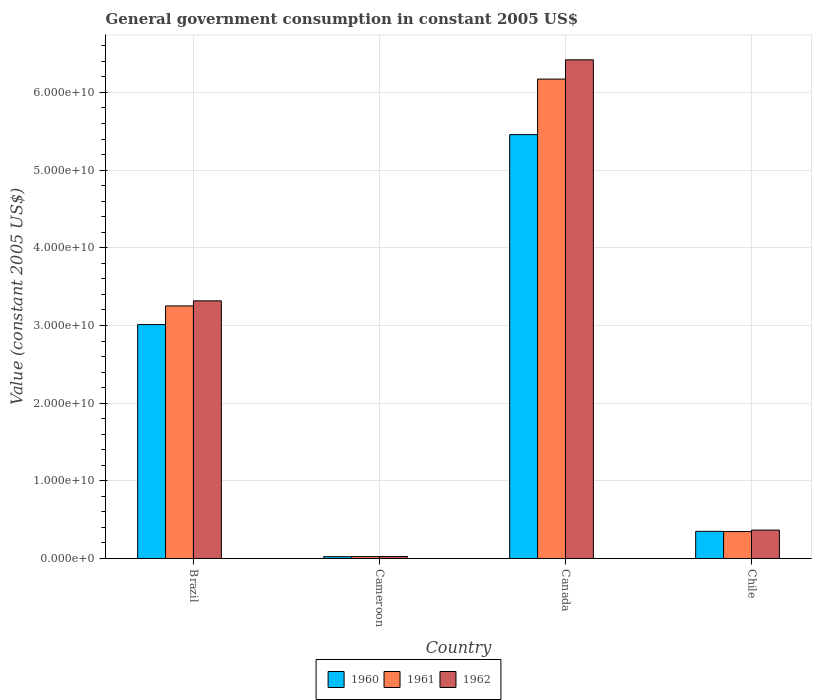How many different coloured bars are there?
Offer a very short reply. 3. How many groups of bars are there?
Provide a succinct answer. 4. Are the number of bars on each tick of the X-axis equal?
Provide a succinct answer. Yes. How many bars are there on the 4th tick from the left?
Offer a terse response. 3. What is the label of the 4th group of bars from the left?
Keep it short and to the point. Chile. What is the government conusmption in 1960 in Cameroon?
Provide a short and direct response. 2.33e+08. Across all countries, what is the maximum government conusmption in 1960?
Your answer should be very brief. 5.46e+1. Across all countries, what is the minimum government conusmption in 1961?
Ensure brevity in your answer.  2.41e+08. In which country was the government conusmption in 1960 maximum?
Offer a terse response. Canada. In which country was the government conusmption in 1961 minimum?
Ensure brevity in your answer.  Cameroon. What is the total government conusmption in 1962 in the graph?
Make the answer very short. 1.01e+11. What is the difference between the government conusmption in 1961 in Cameroon and that in Chile?
Ensure brevity in your answer.  -3.23e+09. What is the difference between the government conusmption in 1961 in Brazil and the government conusmption in 1960 in Canada?
Keep it short and to the point. -2.21e+1. What is the average government conusmption in 1962 per country?
Offer a terse response. 2.53e+1. What is the difference between the government conusmption of/in 1961 and government conusmption of/in 1960 in Brazil?
Your answer should be very brief. 2.40e+09. What is the ratio of the government conusmption in 1960 in Brazil to that in Canada?
Provide a succinct answer. 0.55. Is the government conusmption in 1962 in Cameroon less than that in Chile?
Your answer should be very brief. Yes. What is the difference between the highest and the second highest government conusmption in 1960?
Your answer should be very brief. 2.45e+1. What is the difference between the highest and the lowest government conusmption in 1962?
Keep it short and to the point. 6.40e+1. In how many countries, is the government conusmption in 1960 greater than the average government conusmption in 1960 taken over all countries?
Give a very brief answer. 2. Is the sum of the government conusmption in 1962 in Canada and Chile greater than the maximum government conusmption in 1961 across all countries?
Keep it short and to the point. Yes. What does the 3rd bar from the left in Chile represents?
Give a very brief answer. 1962. Is it the case that in every country, the sum of the government conusmption in 1961 and government conusmption in 1960 is greater than the government conusmption in 1962?
Keep it short and to the point. Yes. Does the graph contain any zero values?
Provide a succinct answer. No. Where does the legend appear in the graph?
Ensure brevity in your answer.  Bottom center. What is the title of the graph?
Provide a succinct answer. General government consumption in constant 2005 US$. What is the label or title of the Y-axis?
Your answer should be very brief. Value (constant 2005 US$). What is the Value (constant 2005 US$) in 1960 in Brazil?
Offer a terse response. 3.01e+1. What is the Value (constant 2005 US$) in 1961 in Brazil?
Your response must be concise. 3.25e+1. What is the Value (constant 2005 US$) in 1962 in Brazil?
Provide a short and direct response. 3.32e+1. What is the Value (constant 2005 US$) of 1960 in Cameroon?
Ensure brevity in your answer.  2.33e+08. What is the Value (constant 2005 US$) in 1961 in Cameroon?
Offer a terse response. 2.41e+08. What is the Value (constant 2005 US$) in 1962 in Cameroon?
Make the answer very short. 2.54e+08. What is the Value (constant 2005 US$) in 1960 in Canada?
Offer a terse response. 5.46e+1. What is the Value (constant 2005 US$) of 1961 in Canada?
Give a very brief answer. 6.17e+1. What is the Value (constant 2005 US$) in 1962 in Canada?
Give a very brief answer. 6.42e+1. What is the Value (constant 2005 US$) in 1960 in Chile?
Your response must be concise. 3.49e+09. What is the Value (constant 2005 US$) in 1961 in Chile?
Your answer should be very brief. 3.47e+09. What is the Value (constant 2005 US$) of 1962 in Chile?
Your response must be concise. 3.66e+09. Across all countries, what is the maximum Value (constant 2005 US$) of 1960?
Keep it short and to the point. 5.46e+1. Across all countries, what is the maximum Value (constant 2005 US$) in 1961?
Your answer should be very brief. 6.17e+1. Across all countries, what is the maximum Value (constant 2005 US$) of 1962?
Provide a succinct answer. 6.42e+1. Across all countries, what is the minimum Value (constant 2005 US$) in 1960?
Keep it short and to the point. 2.33e+08. Across all countries, what is the minimum Value (constant 2005 US$) of 1961?
Offer a terse response. 2.41e+08. Across all countries, what is the minimum Value (constant 2005 US$) of 1962?
Give a very brief answer. 2.54e+08. What is the total Value (constant 2005 US$) of 1960 in the graph?
Keep it short and to the point. 8.84e+1. What is the total Value (constant 2005 US$) of 1961 in the graph?
Make the answer very short. 9.80e+1. What is the total Value (constant 2005 US$) in 1962 in the graph?
Provide a succinct answer. 1.01e+11. What is the difference between the Value (constant 2005 US$) of 1960 in Brazil and that in Cameroon?
Provide a succinct answer. 2.99e+1. What is the difference between the Value (constant 2005 US$) in 1961 in Brazil and that in Cameroon?
Make the answer very short. 3.23e+1. What is the difference between the Value (constant 2005 US$) of 1962 in Brazil and that in Cameroon?
Offer a very short reply. 3.29e+1. What is the difference between the Value (constant 2005 US$) in 1960 in Brazil and that in Canada?
Your response must be concise. -2.45e+1. What is the difference between the Value (constant 2005 US$) of 1961 in Brazil and that in Canada?
Provide a short and direct response. -2.92e+1. What is the difference between the Value (constant 2005 US$) of 1962 in Brazil and that in Canada?
Keep it short and to the point. -3.10e+1. What is the difference between the Value (constant 2005 US$) in 1960 in Brazil and that in Chile?
Offer a very short reply. 2.66e+1. What is the difference between the Value (constant 2005 US$) of 1961 in Brazil and that in Chile?
Your response must be concise. 2.90e+1. What is the difference between the Value (constant 2005 US$) of 1962 in Brazil and that in Chile?
Ensure brevity in your answer.  2.95e+1. What is the difference between the Value (constant 2005 US$) of 1960 in Cameroon and that in Canada?
Give a very brief answer. -5.43e+1. What is the difference between the Value (constant 2005 US$) of 1961 in Cameroon and that in Canada?
Provide a succinct answer. -6.15e+1. What is the difference between the Value (constant 2005 US$) in 1962 in Cameroon and that in Canada?
Provide a succinct answer. -6.40e+1. What is the difference between the Value (constant 2005 US$) of 1960 in Cameroon and that in Chile?
Your response must be concise. -3.26e+09. What is the difference between the Value (constant 2005 US$) of 1961 in Cameroon and that in Chile?
Ensure brevity in your answer.  -3.23e+09. What is the difference between the Value (constant 2005 US$) of 1962 in Cameroon and that in Chile?
Your response must be concise. -3.40e+09. What is the difference between the Value (constant 2005 US$) in 1960 in Canada and that in Chile?
Give a very brief answer. 5.11e+1. What is the difference between the Value (constant 2005 US$) in 1961 in Canada and that in Chile?
Your response must be concise. 5.83e+1. What is the difference between the Value (constant 2005 US$) of 1962 in Canada and that in Chile?
Offer a very short reply. 6.05e+1. What is the difference between the Value (constant 2005 US$) in 1960 in Brazil and the Value (constant 2005 US$) in 1961 in Cameroon?
Offer a terse response. 2.99e+1. What is the difference between the Value (constant 2005 US$) in 1960 in Brazil and the Value (constant 2005 US$) in 1962 in Cameroon?
Provide a short and direct response. 2.99e+1. What is the difference between the Value (constant 2005 US$) of 1961 in Brazil and the Value (constant 2005 US$) of 1962 in Cameroon?
Provide a succinct answer. 3.23e+1. What is the difference between the Value (constant 2005 US$) in 1960 in Brazil and the Value (constant 2005 US$) in 1961 in Canada?
Your answer should be compact. -3.16e+1. What is the difference between the Value (constant 2005 US$) of 1960 in Brazil and the Value (constant 2005 US$) of 1962 in Canada?
Give a very brief answer. -3.41e+1. What is the difference between the Value (constant 2005 US$) in 1961 in Brazil and the Value (constant 2005 US$) in 1962 in Canada?
Offer a very short reply. -3.17e+1. What is the difference between the Value (constant 2005 US$) of 1960 in Brazil and the Value (constant 2005 US$) of 1961 in Chile?
Provide a short and direct response. 2.66e+1. What is the difference between the Value (constant 2005 US$) of 1960 in Brazil and the Value (constant 2005 US$) of 1962 in Chile?
Offer a terse response. 2.65e+1. What is the difference between the Value (constant 2005 US$) in 1961 in Brazil and the Value (constant 2005 US$) in 1962 in Chile?
Offer a very short reply. 2.89e+1. What is the difference between the Value (constant 2005 US$) of 1960 in Cameroon and the Value (constant 2005 US$) of 1961 in Canada?
Give a very brief answer. -6.15e+1. What is the difference between the Value (constant 2005 US$) of 1960 in Cameroon and the Value (constant 2005 US$) of 1962 in Canada?
Offer a very short reply. -6.40e+1. What is the difference between the Value (constant 2005 US$) of 1961 in Cameroon and the Value (constant 2005 US$) of 1962 in Canada?
Offer a very short reply. -6.40e+1. What is the difference between the Value (constant 2005 US$) in 1960 in Cameroon and the Value (constant 2005 US$) in 1961 in Chile?
Keep it short and to the point. -3.24e+09. What is the difference between the Value (constant 2005 US$) of 1960 in Cameroon and the Value (constant 2005 US$) of 1962 in Chile?
Your answer should be compact. -3.42e+09. What is the difference between the Value (constant 2005 US$) in 1961 in Cameroon and the Value (constant 2005 US$) in 1962 in Chile?
Make the answer very short. -3.42e+09. What is the difference between the Value (constant 2005 US$) of 1960 in Canada and the Value (constant 2005 US$) of 1961 in Chile?
Offer a terse response. 5.11e+1. What is the difference between the Value (constant 2005 US$) in 1960 in Canada and the Value (constant 2005 US$) in 1962 in Chile?
Provide a short and direct response. 5.09e+1. What is the difference between the Value (constant 2005 US$) of 1961 in Canada and the Value (constant 2005 US$) of 1962 in Chile?
Offer a terse response. 5.81e+1. What is the average Value (constant 2005 US$) in 1960 per country?
Keep it short and to the point. 2.21e+1. What is the average Value (constant 2005 US$) in 1961 per country?
Your answer should be very brief. 2.45e+1. What is the average Value (constant 2005 US$) in 1962 per country?
Offer a very short reply. 2.53e+1. What is the difference between the Value (constant 2005 US$) of 1960 and Value (constant 2005 US$) of 1961 in Brazil?
Your answer should be compact. -2.40e+09. What is the difference between the Value (constant 2005 US$) in 1960 and Value (constant 2005 US$) in 1962 in Brazil?
Offer a terse response. -3.06e+09. What is the difference between the Value (constant 2005 US$) in 1961 and Value (constant 2005 US$) in 1962 in Brazil?
Make the answer very short. -6.55e+08. What is the difference between the Value (constant 2005 US$) in 1960 and Value (constant 2005 US$) in 1961 in Cameroon?
Give a very brief answer. -7.57e+06. What is the difference between the Value (constant 2005 US$) of 1960 and Value (constant 2005 US$) of 1962 in Cameroon?
Give a very brief answer. -2.04e+07. What is the difference between the Value (constant 2005 US$) of 1961 and Value (constant 2005 US$) of 1962 in Cameroon?
Keep it short and to the point. -1.29e+07. What is the difference between the Value (constant 2005 US$) of 1960 and Value (constant 2005 US$) of 1961 in Canada?
Offer a terse response. -7.15e+09. What is the difference between the Value (constant 2005 US$) of 1960 and Value (constant 2005 US$) of 1962 in Canada?
Your response must be concise. -9.63e+09. What is the difference between the Value (constant 2005 US$) in 1961 and Value (constant 2005 US$) in 1962 in Canada?
Your answer should be very brief. -2.48e+09. What is the difference between the Value (constant 2005 US$) in 1960 and Value (constant 2005 US$) in 1961 in Chile?
Offer a terse response. 2.27e+07. What is the difference between the Value (constant 2005 US$) of 1960 and Value (constant 2005 US$) of 1962 in Chile?
Keep it short and to the point. -1.64e+08. What is the difference between the Value (constant 2005 US$) of 1961 and Value (constant 2005 US$) of 1962 in Chile?
Your answer should be compact. -1.87e+08. What is the ratio of the Value (constant 2005 US$) in 1960 in Brazil to that in Cameroon?
Provide a short and direct response. 129.1. What is the ratio of the Value (constant 2005 US$) in 1961 in Brazil to that in Cameroon?
Give a very brief answer. 135.01. What is the ratio of the Value (constant 2005 US$) of 1962 in Brazil to that in Cameroon?
Your response must be concise. 130.74. What is the ratio of the Value (constant 2005 US$) of 1960 in Brazil to that in Canada?
Your response must be concise. 0.55. What is the ratio of the Value (constant 2005 US$) of 1961 in Brazil to that in Canada?
Ensure brevity in your answer.  0.53. What is the ratio of the Value (constant 2005 US$) in 1962 in Brazil to that in Canada?
Your answer should be compact. 0.52. What is the ratio of the Value (constant 2005 US$) of 1960 in Brazil to that in Chile?
Provide a succinct answer. 8.62. What is the ratio of the Value (constant 2005 US$) in 1961 in Brazil to that in Chile?
Provide a short and direct response. 9.37. What is the ratio of the Value (constant 2005 US$) in 1962 in Brazil to that in Chile?
Give a very brief answer. 9.07. What is the ratio of the Value (constant 2005 US$) in 1960 in Cameroon to that in Canada?
Your response must be concise. 0. What is the ratio of the Value (constant 2005 US$) in 1961 in Cameroon to that in Canada?
Your answer should be compact. 0. What is the ratio of the Value (constant 2005 US$) of 1962 in Cameroon to that in Canada?
Your answer should be compact. 0. What is the ratio of the Value (constant 2005 US$) of 1960 in Cameroon to that in Chile?
Your response must be concise. 0.07. What is the ratio of the Value (constant 2005 US$) in 1961 in Cameroon to that in Chile?
Provide a short and direct response. 0.07. What is the ratio of the Value (constant 2005 US$) in 1962 in Cameroon to that in Chile?
Provide a succinct answer. 0.07. What is the ratio of the Value (constant 2005 US$) in 1960 in Canada to that in Chile?
Offer a terse response. 15.62. What is the ratio of the Value (constant 2005 US$) of 1961 in Canada to that in Chile?
Provide a short and direct response. 17.78. What is the ratio of the Value (constant 2005 US$) of 1962 in Canada to that in Chile?
Your answer should be very brief. 17.55. What is the difference between the highest and the second highest Value (constant 2005 US$) in 1960?
Offer a terse response. 2.45e+1. What is the difference between the highest and the second highest Value (constant 2005 US$) in 1961?
Provide a succinct answer. 2.92e+1. What is the difference between the highest and the second highest Value (constant 2005 US$) of 1962?
Offer a very short reply. 3.10e+1. What is the difference between the highest and the lowest Value (constant 2005 US$) in 1960?
Provide a succinct answer. 5.43e+1. What is the difference between the highest and the lowest Value (constant 2005 US$) in 1961?
Your answer should be very brief. 6.15e+1. What is the difference between the highest and the lowest Value (constant 2005 US$) of 1962?
Offer a very short reply. 6.40e+1. 